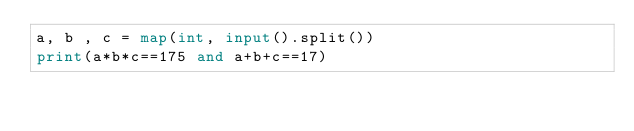<code> <loc_0><loc_0><loc_500><loc_500><_Python_>a, b , c = map(int, input().split())
print(a*b*c==175 and a+b+c==17)</code> 